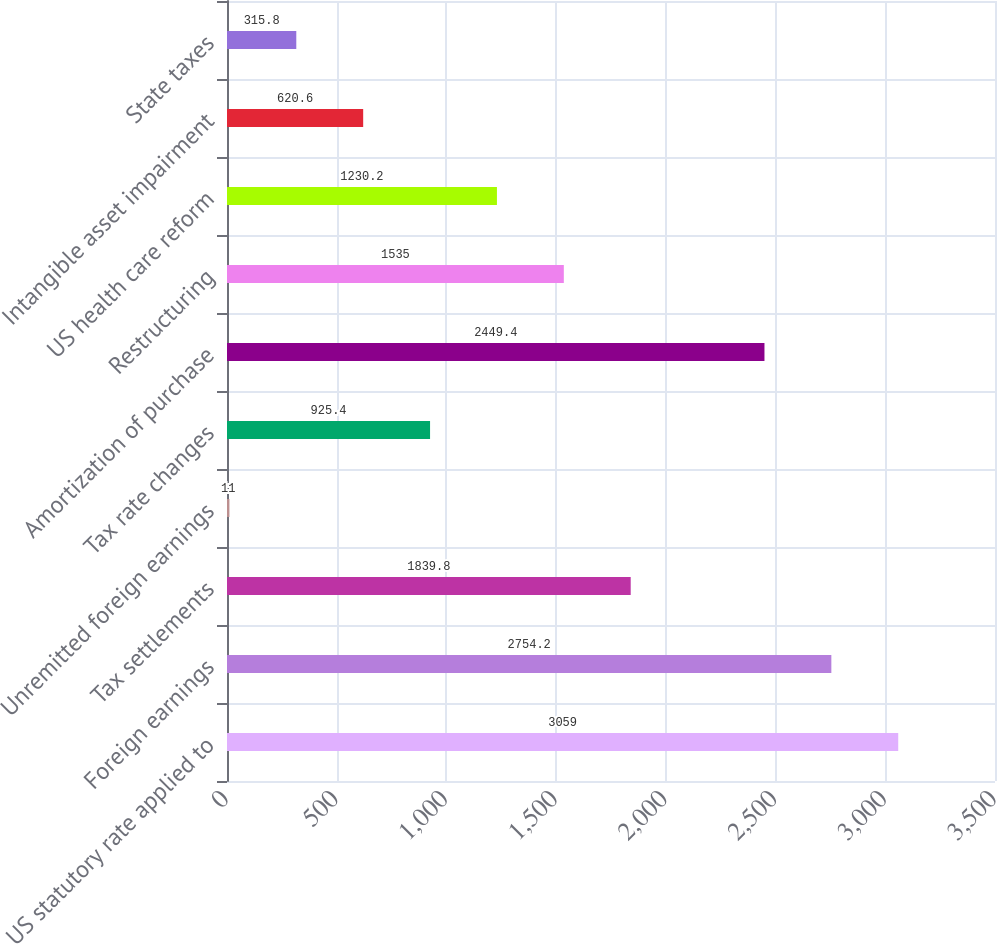<chart> <loc_0><loc_0><loc_500><loc_500><bar_chart><fcel>US statutory rate applied to<fcel>Foreign earnings<fcel>Tax settlements<fcel>Unremitted foreign earnings<fcel>Tax rate changes<fcel>Amortization of purchase<fcel>Restructuring<fcel>US health care reform<fcel>Intangible asset impairment<fcel>State taxes<nl><fcel>3059<fcel>2754.2<fcel>1839.8<fcel>11<fcel>925.4<fcel>2449.4<fcel>1535<fcel>1230.2<fcel>620.6<fcel>315.8<nl></chart> 